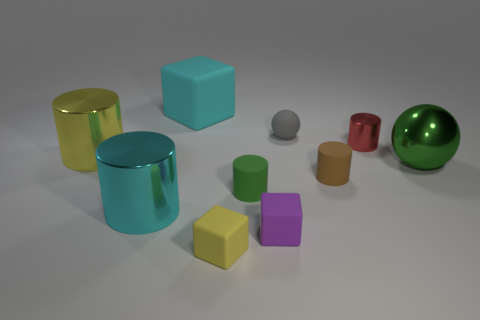Are there the same number of green things that are to the right of the tiny green object and tiny metallic cylinders that are behind the yellow rubber cube?
Offer a very short reply. Yes. Is there anything else that has the same size as the red cylinder?
Your answer should be compact. Yes. How many green things are big shiny balls or matte cylinders?
Your answer should be compact. 2. How many cyan rubber blocks are the same size as the cyan matte object?
Your answer should be very brief. 0. The metallic thing that is behind the big cyan cylinder and to the left of the yellow rubber thing is what color?
Your answer should be very brief. Yellow. Are there more cyan matte blocks right of the brown matte cylinder than tiny yellow objects?
Provide a short and direct response. No. Is there a green thing?
Ensure brevity in your answer.  Yes. Is the color of the small sphere the same as the shiny sphere?
Give a very brief answer. No. How many tiny objects are green things or rubber spheres?
Ensure brevity in your answer.  2. Is there anything else of the same color as the matte sphere?
Provide a short and direct response. No. 